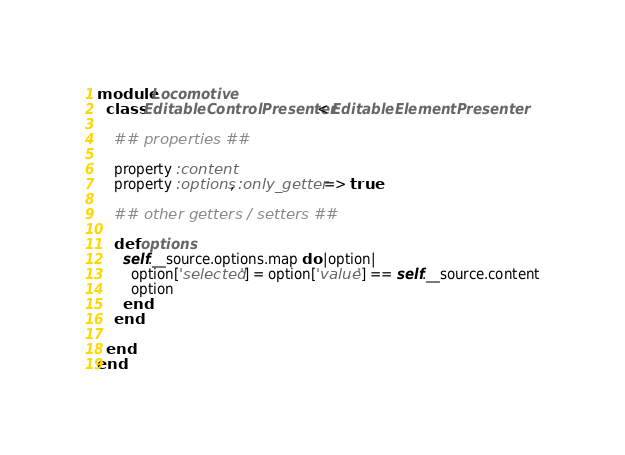<code> <loc_0><loc_0><loc_500><loc_500><_Ruby_>module Locomotive
  class EditableControlPresenter < EditableElementPresenter

    ## properties ##

    property :content
    property :options, :only_getter => true

    ## other getters / setters ##

    def options
      self.__source.options.map do |option|
        option['selected'] = option['value'] == self.__source.content
        option
      end
    end

  end
end
</code> 